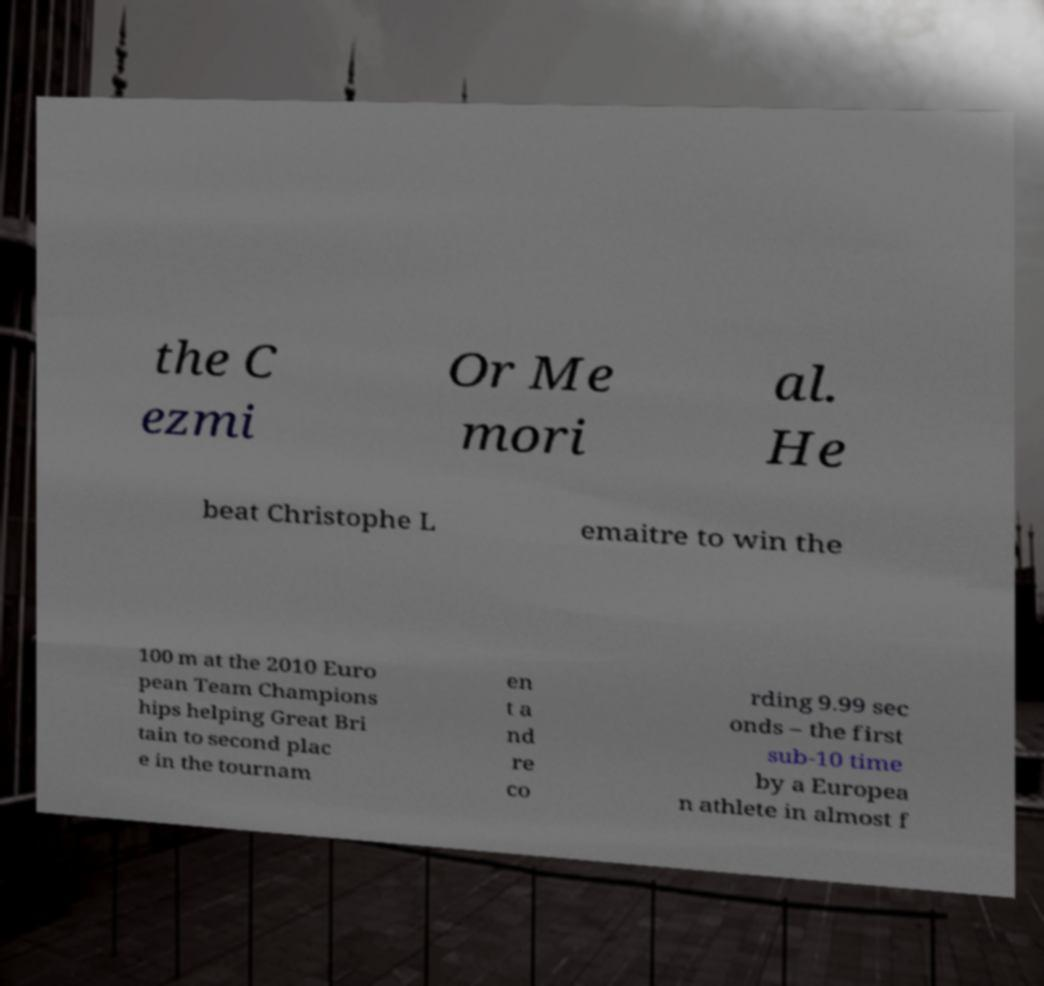Can you read and provide the text displayed in the image?This photo seems to have some interesting text. Can you extract and type it out for me? the C ezmi Or Me mori al. He beat Christophe L emaitre to win the 100 m at the 2010 Euro pean Team Champions hips helping Great Bri tain to second plac e in the tournam en t a nd re co rding 9.99 sec onds – the first sub-10 time by a Europea n athlete in almost f 